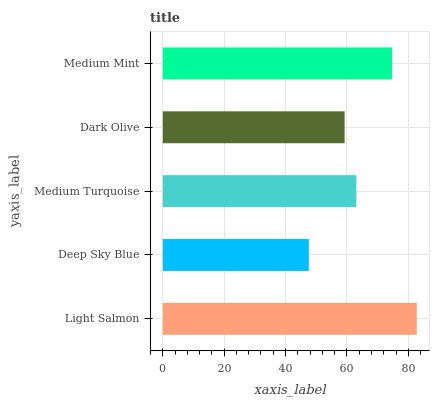Is Deep Sky Blue the minimum?
Answer yes or no. Yes. Is Light Salmon the maximum?
Answer yes or no. Yes. Is Medium Turquoise the minimum?
Answer yes or no. No. Is Medium Turquoise the maximum?
Answer yes or no. No. Is Medium Turquoise greater than Deep Sky Blue?
Answer yes or no. Yes. Is Deep Sky Blue less than Medium Turquoise?
Answer yes or no. Yes. Is Deep Sky Blue greater than Medium Turquoise?
Answer yes or no. No. Is Medium Turquoise less than Deep Sky Blue?
Answer yes or no. No. Is Medium Turquoise the high median?
Answer yes or no. Yes. Is Medium Turquoise the low median?
Answer yes or no. Yes. Is Dark Olive the high median?
Answer yes or no. No. Is Deep Sky Blue the low median?
Answer yes or no. No. 